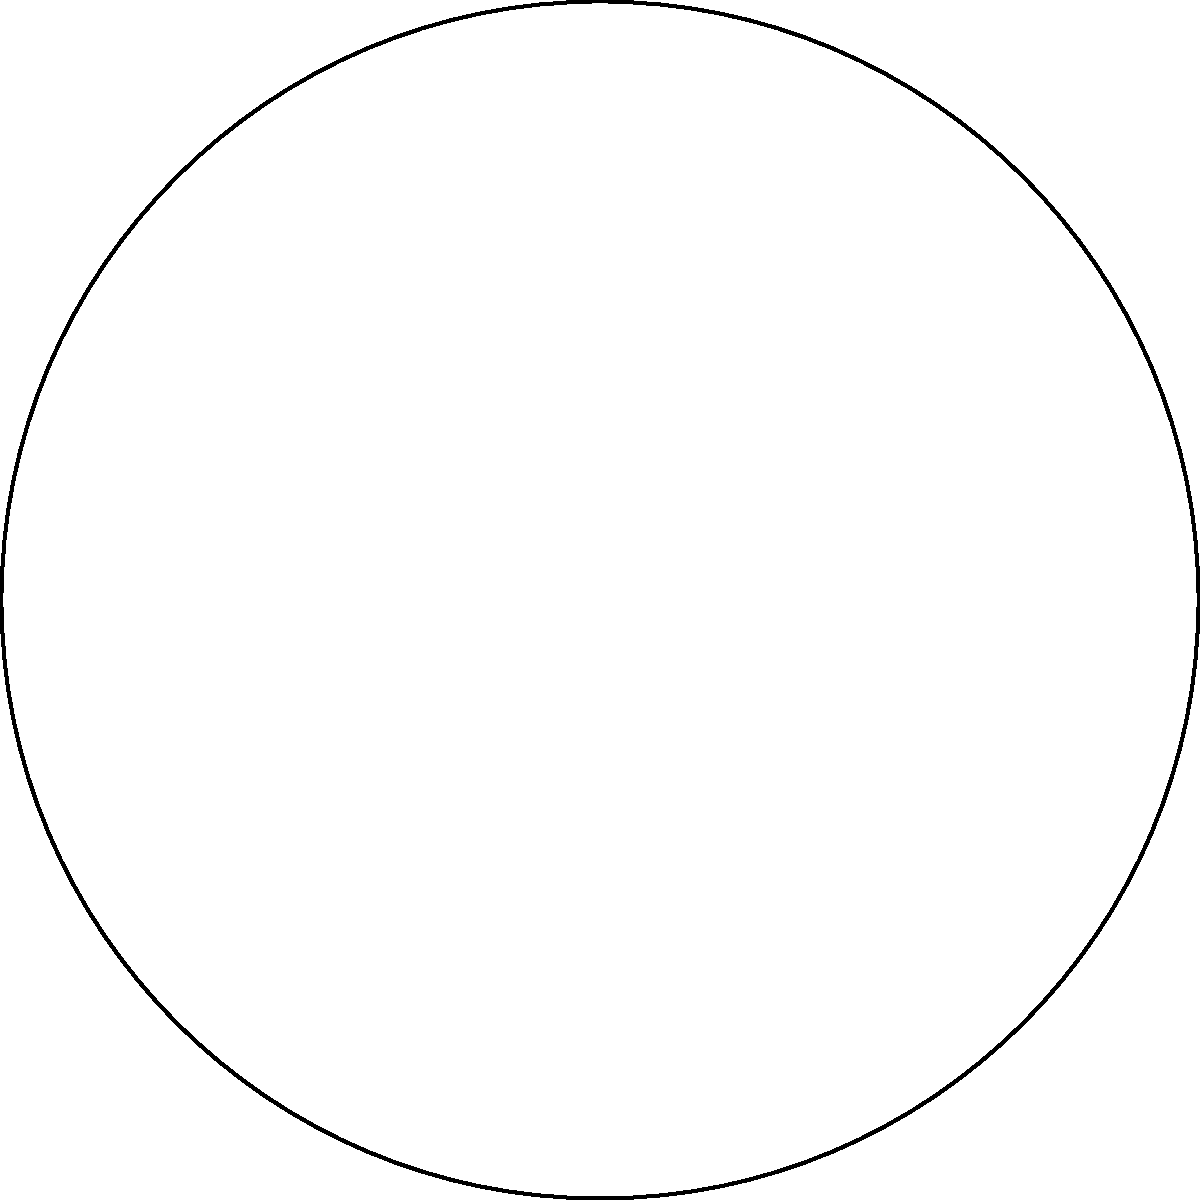As a stuttering awareness advocate, you're designing a cone-shaped megaphone for public speaking events. The megaphone has a slant height of 5 inches and a base radius of 3 inches. Calculate the surface area of the megaphone, excluding the base. Round your answer to the nearest square inch. Let's approach this step-by-step:

1) The formula for the lateral surface area of a cone (excluding the base) is:
   $$A = \pi rs$$
   where $r$ is the radius of the base and $s$ is the slant height.

2) We're given:
   $r = 3$ inches (base radius)
   $s = 5$ inches (slant height)

3) Let's substitute these values into our formula:
   $$A = \pi (3)(5)$$

4) Simplify:
   $$A = 15\pi$$

5) Calculate:
   $$A \approx 47.12389...$$

6) Rounding to the nearest square inch:
   $$A \approx 47 \text{ square inches}$$

This surface area represents the amount of material needed to cover the curved part of your cone-shaped megaphone, which will help amplify your voice during stuttering awareness events.
Answer: 47 square inches 